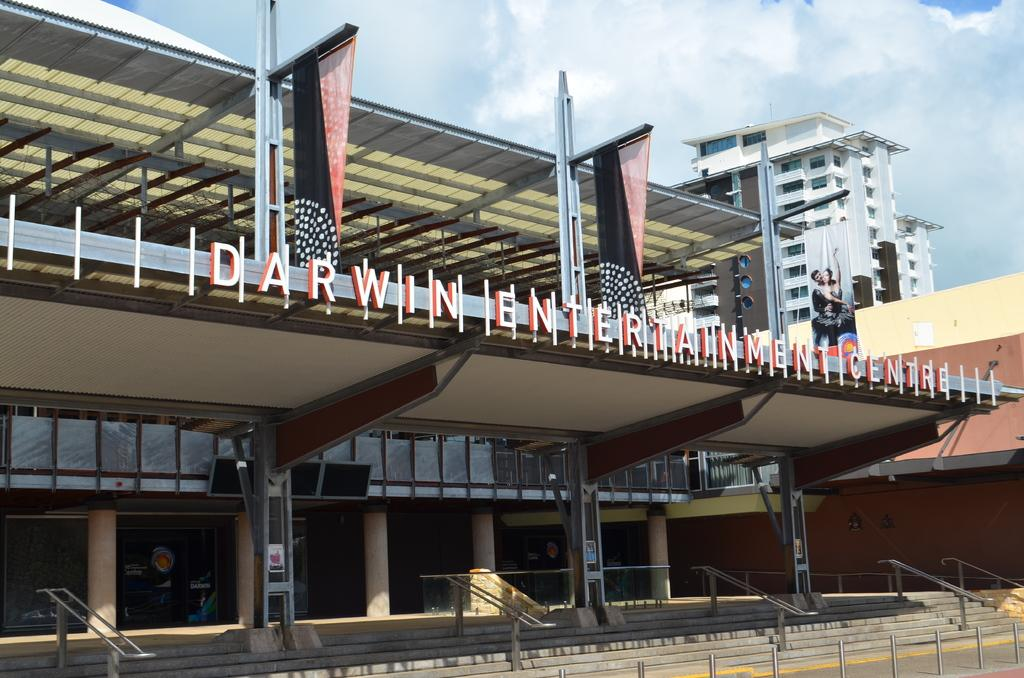What type of structures can be seen in the image? There are buildings in the image. What architectural feature is present at the bottom of the image? There are steps at the bottom of the image. What is hanging on the right side of the image? There is a banner on the right side of the image. What can be seen in the sky in the image? There are clouds in the sky. What type of sheet is being used to cover the holiday decorations in the image? There is no sheet or holiday decorations present in the image. 